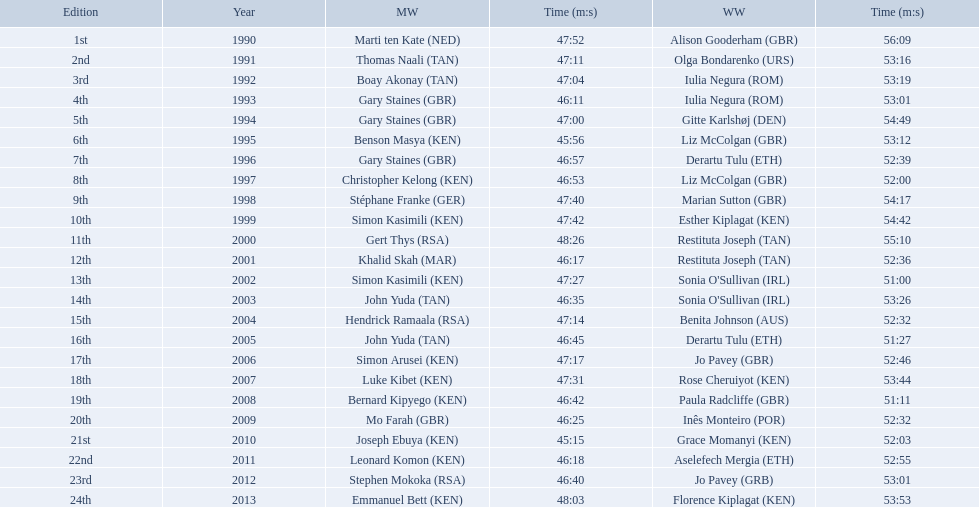Which of the runner in the great south run were women? Alison Gooderham (GBR), Olga Bondarenko (URS), Iulia Negura (ROM), Iulia Negura (ROM), Gitte Karlshøj (DEN), Liz McColgan (GBR), Derartu Tulu (ETH), Liz McColgan (GBR), Marian Sutton (GBR), Esther Kiplagat (KEN), Restituta Joseph (TAN), Restituta Joseph (TAN), Sonia O'Sullivan (IRL), Sonia O'Sullivan (IRL), Benita Johnson (AUS), Derartu Tulu (ETH), Jo Pavey (GBR), Rose Cheruiyot (KEN), Paula Radcliffe (GBR), Inês Monteiro (POR), Grace Momanyi (KEN), Aselefech Mergia (ETH), Jo Pavey (GRB), Florence Kiplagat (KEN). Of those women, which ones had a time of at least 53 minutes? Alison Gooderham (GBR), Olga Bondarenko (URS), Iulia Negura (ROM), Iulia Negura (ROM), Gitte Karlshøj (DEN), Liz McColgan (GBR), Marian Sutton (GBR), Esther Kiplagat (KEN), Restituta Joseph (TAN), Sonia O'Sullivan (IRL), Rose Cheruiyot (KEN), Jo Pavey (GRB), Florence Kiplagat (KEN). Between those women, which ones did not go over 53 minutes? Olga Bondarenko (URS), Iulia Negura (ROM), Iulia Negura (ROM), Liz McColgan (GBR), Sonia O'Sullivan (IRL), Rose Cheruiyot (KEN), Jo Pavey (GRB), Florence Kiplagat (KEN). Of those 8, what were the three slowest times? Sonia O'Sullivan (IRL), Rose Cheruiyot (KEN), Florence Kiplagat (KEN). Between only those 3 women, which runner had the fastest time? Sonia O'Sullivan (IRL). What was this women's time? 53:26. Who were all the runners' times between 1990 and 2013? 47:52, 56:09, 47:11, 53:16, 47:04, 53:19, 46:11, 53:01, 47:00, 54:49, 45:56, 53:12, 46:57, 52:39, 46:53, 52:00, 47:40, 54:17, 47:42, 54:42, 48:26, 55:10, 46:17, 52:36, 47:27, 51:00, 46:35, 53:26, 47:14, 52:32, 46:45, 51:27, 47:17, 52:46, 47:31, 53:44, 46:42, 51:11, 46:25, 52:32, 45:15, 52:03, 46:18, 52:55, 46:40, 53:01, 48:03, 53:53. Which was the fastest time? 45:15. Can you give me this table as a dict? {'header': ['Edition', 'Year', 'MW', 'Time (m:s)', 'WW', 'Time (m:s)'], 'rows': [['1st', '1990', 'Marti ten Kate\xa0(NED)', '47:52', 'Alison Gooderham\xa0(GBR)', '56:09'], ['2nd', '1991', 'Thomas Naali\xa0(TAN)', '47:11', 'Olga Bondarenko\xa0(URS)', '53:16'], ['3rd', '1992', 'Boay Akonay\xa0(TAN)', '47:04', 'Iulia Negura\xa0(ROM)', '53:19'], ['4th', '1993', 'Gary Staines\xa0(GBR)', '46:11', 'Iulia Negura\xa0(ROM)', '53:01'], ['5th', '1994', 'Gary Staines\xa0(GBR)', '47:00', 'Gitte Karlshøj\xa0(DEN)', '54:49'], ['6th', '1995', 'Benson Masya\xa0(KEN)', '45:56', 'Liz McColgan\xa0(GBR)', '53:12'], ['7th', '1996', 'Gary Staines\xa0(GBR)', '46:57', 'Derartu Tulu\xa0(ETH)', '52:39'], ['8th', '1997', 'Christopher Kelong\xa0(KEN)', '46:53', 'Liz McColgan\xa0(GBR)', '52:00'], ['9th', '1998', 'Stéphane Franke\xa0(GER)', '47:40', 'Marian Sutton\xa0(GBR)', '54:17'], ['10th', '1999', 'Simon Kasimili\xa0(KEN)', '47:42', 'Esther Kiplagat\xa0(KEN)', '54:42'], ['11th', '2000', 'Gert Thys\xa0(RSA)', '48:26', 'Restituta Joseph\xa0(TAN)', '55:10'], ['12th', '2001', 'Khalid Skah\xa0(MAR)', '46:17', 'Restituta Joseph\xa0(TAN)', '52:36'], ['13th', '2002', 'Simon Kasimili\xa0(KEN)', '47:27', "Sonia O'Sullivan\xa0(IRL)", '51:00'], ['14th', '2003', 'John Yuda\xa0(TAN)', '46:35', "Sonia O'Sullivan\xa0(IRL)", '53:26'], ['15th', '2004', 'Hendrick Ramaala\xa0(RSA)', '47:14', 'Benita Johnson\xa0(AUS)', '52:32'], ['16th', '2005', 'John Yuda\xa0(TAN)', '46:45', 'Derartu Tulu\xa0(ETH)', '51:27'], ['17th', '2006', 'Simon Arusei\xa0(KEN)', '47:17', 'Jo Pavey\xa0(GBR)', '52:46'], ['18th', '2007', 'Luke Kibet\xa0(KEN)', '47:31', 'Rose Cheruiyot\xa0(KEN)', '53:44'], ['19th', '2008', 'Bernard Kipyego\xa0(KEN)', '46:42', 'Paula Radcliffe\xa0(GBR)', '51:11'], ['20th', '2009', 'Mo Farah\xa0(GBR)', '46:25', 'Inês Monteiro\xa0(POR)', '52:32'], ['21st', '2010', 'Joseph Ebuya\xa0(KEN)', '45:15', 'Grace Momanyi\xa0(KEN)', '52:03'], ['22nd', '2011', 'Leonard Komon\xa0(KEN)', '46:18', 'Aselefech Mergia\xa0(ETH)', '52:55'], ['23rd', '2012', 'Stephen Mokoka\xa0(RSA)', '46:40', 'Jo Pavey\xa0(GRB)', '53:01'], ['24th', '2013', 'Emmanuel Bett\xa0(KEN)', '48:03', 'Florence Kiplagat\xa0(KEN)', '53:53']]} Who ran that time? Joseph Ebuya (KEN). 